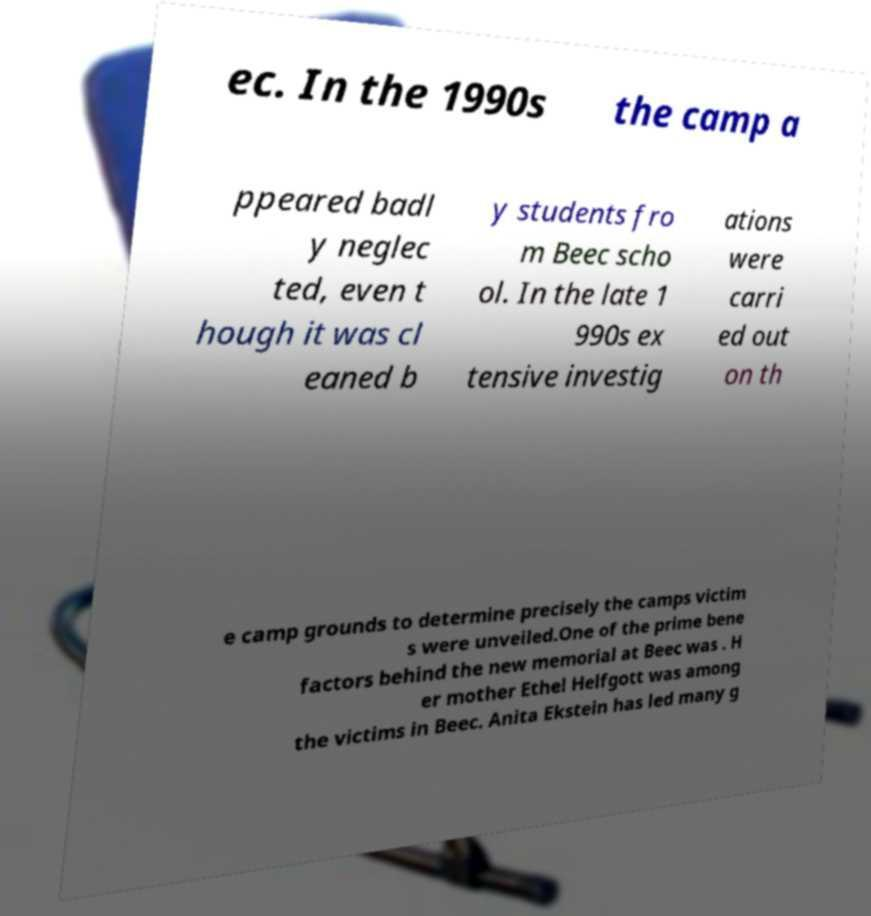What messages or text are displayed in this image? I need them in a readable, typed format. ec. In the 1990s the camp a ppeared badl y neglec ted, even t hough it was cl eaned b y students fro m Beec scho ol. In the late 1 990s ex tensive investig ations were carri ed out on th e camp grounds to determine precisely the camps victim s were unveiled.One of the prime bene factors behind the new memorial at Beec was . H er mother Ethel Helfgott was among the victims in Beec. Anita Ekstein has led many g 